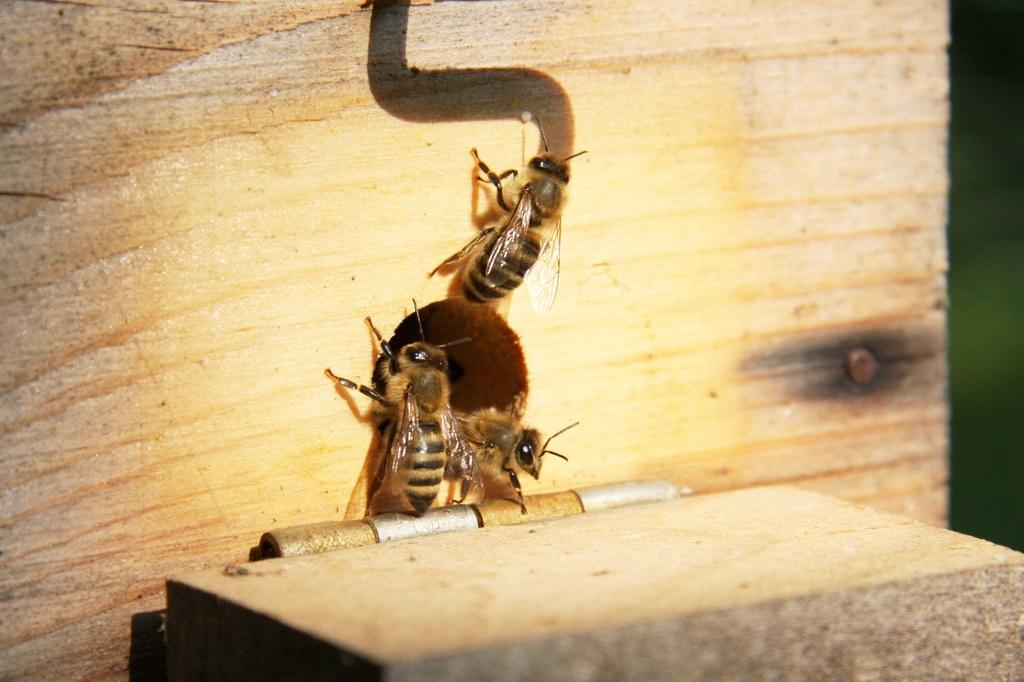What material is the plank in the image made of? The wooden plank in the image is made of wood. What insects can be seen on the wooden plank? Three bees are climbing on the wooden plank. What type of furniture is present in the image? There is a desk in the image. What type of current is flowing through the wooden plank in the image? There is no current flowing through the wooden plank in the image; it is a static object. 